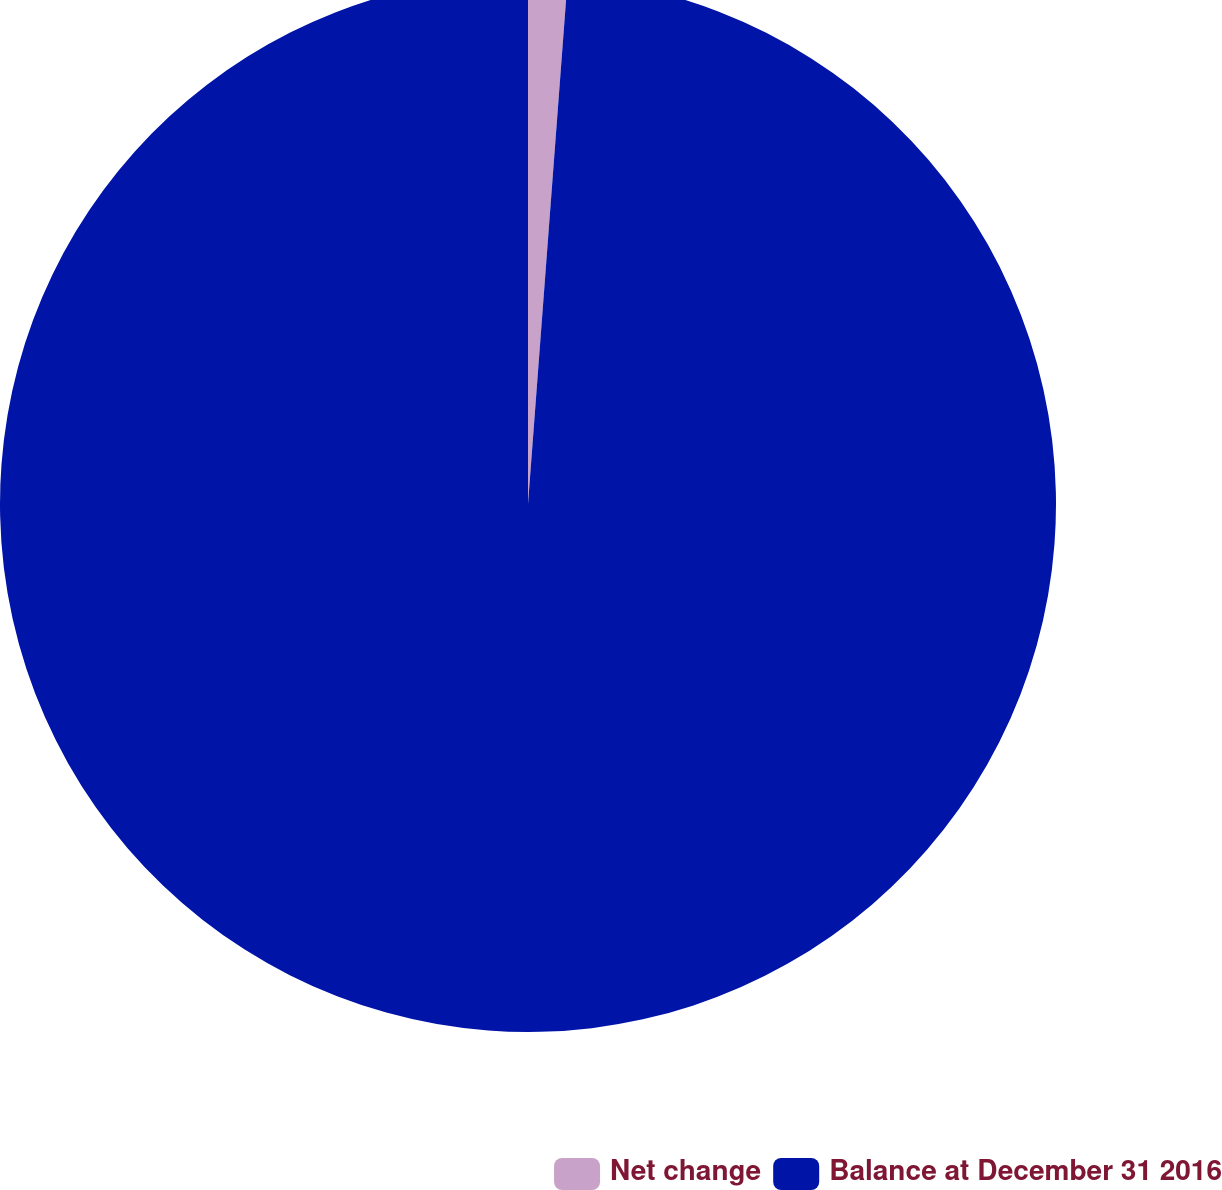Convert chart. <chart><loc_0><loc_0><loc_500><loc_500><pie_chart><fcel>Net change<fcel>Balance at December 31 2016<nl><fcel>1.2%<fcel>98.8%<nl></chart> 